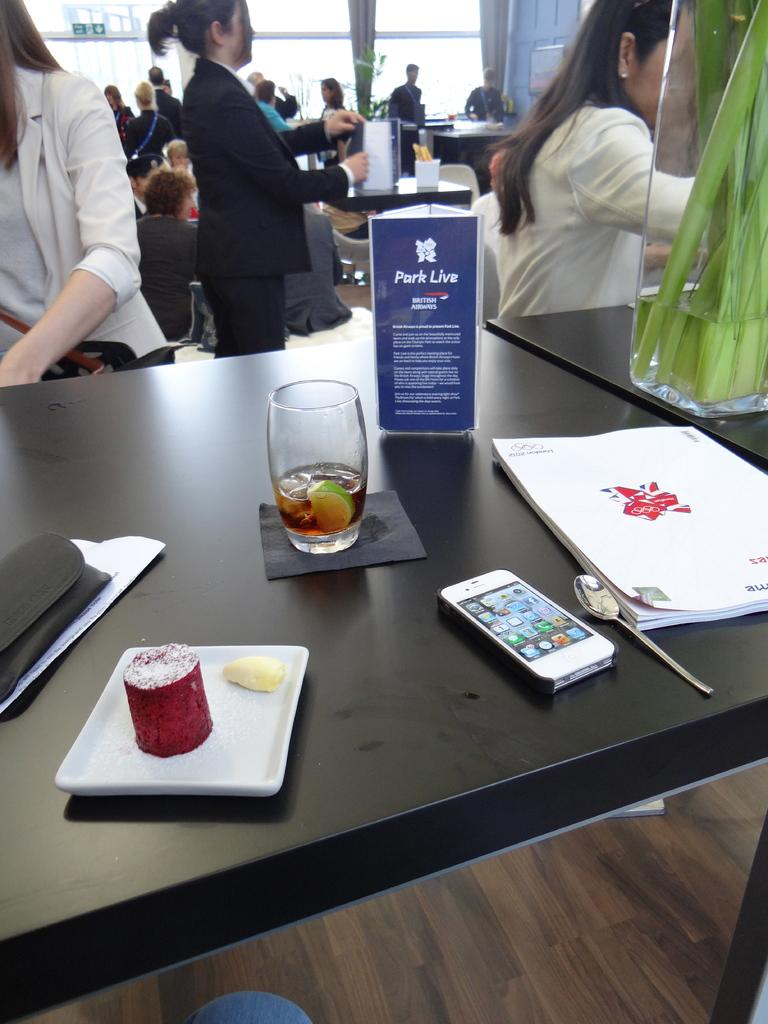What color is the table in the image? The table in the image is black. What type of item related to a park can be seen on the table? There is a park live brochure on the table. What other items can be seen on the table? There is a book, a spoon, an iPhone, a black purse, and a drink on the table. What is happening in the background of the image? There are people sitting in the background of the image. What type of metal is the ghost using to communicate with the people in the image? There is no ghost present in the image, and therefore no metal or communication with people can be observed. 